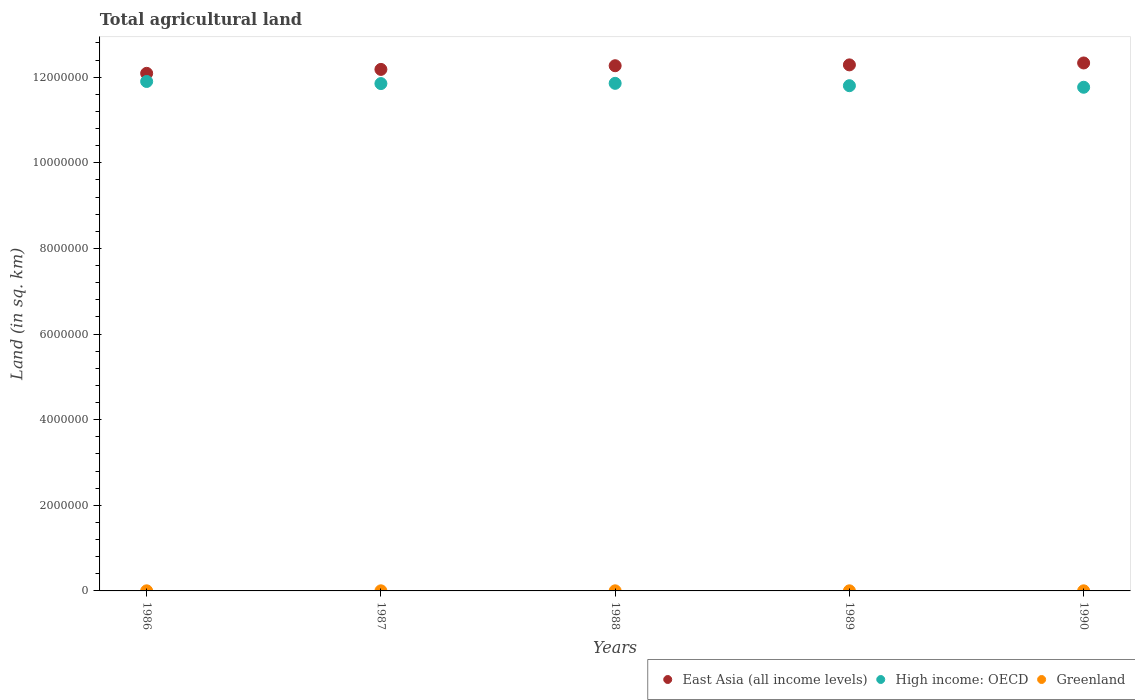How many different coloured dotlines are there?
Make the answer very short. 3. Is the number of dotlines equal to the number of legend labels?
Ensure brevity in your answer.  Yes. What is the total agricultural land in Greenland in 1988?
Your response must be concise. 2354. Across all years, what is the maximum total agricultural land in High income: OECD?
Ensure brevity in your answer.  1.19e+07. Across all years, what is the minimum total agricultural land in High income: OECD?
Give a very brief answer. 1.18e+07. In which year was the total agricultural land in East Asia (all income levels) minimum?
Provide a succinct answer. 1986. What is the total total agricultural land in High income: OECD in the graph?
Provide a short and direct response. 5.92e+07. What is the difference between the total agricultural land in East Asia (all income levels) in 1986 and that in 1987?
Offer a very short reply. -9.19e+04. What is the difference between the total agricultural land in Greenland in 1986 and the total agricultural land in High income: OECD in 1987?
Your response must be concise. -1.18e+07. What is the average total agricultural land in Greenland per year?
Provide a short and direct response. 2354.2. In the year 1986, what is the difference between the total agricultural land in East Asia (all income levels) and total agricultural land in High income: OECD?
Make the answer very short. 1.90e+05. What is the ratio of the total agricultural land in Greenland in 1988 to that in 1990?
Make the answer very short. 1. Is the total agricultural land in East Asia (all income levels) in 1988 less than that in 1989?
Your answer should be compact. Yes. What is the difference between the highest and the lowest total agricultural land in High income: OECD?
Give a very brief answer. 1.35e+05. Does the total agricultural land in High income: OECD monotonically increase over the years?
Give a very brief answer. No. Is the total agricultural land in High income: OECD strictly greater than the total agricultural land in East Asia (all income levels) over the years?
Your answer should be compact. No. How many dotlines are there?
Offer a terse response. 3. How many years are there in the graph?
Provide a succinct answer. 5. What is the difference between two consecutive major ticks on the Y-axis?
Provide a succinct answer. 2.00e+06. Are the values on the major ticks of Y-axis written in scientific E-notation?
Give a very brief answer. No. Does the graph contain any zero values?
Your answer should be compact. No. Where does the legend appear in the graph?
Offer a terse response. Bottom right. How many legend labels are there?
Offer a very short reply. 3. How are the legend labels stacked?
Offer a very short reply. Horizontal. What is the title of the graph?
Give a very brief answer. Total agricultural land. What is the label or title of the X-axis?
Keep it short and to the point. Years. What is the label or title of the Y-axis?
Keep it short and to the point. Land (in sq. km). What is the Land (in sq. km) of East Asia (all income levels) in 1986?
Your answer should be compact. 1.21e+07. What is the Land (in sq. km) of High income: OECD in 1986?
Make the answer very short. 1.19e+07. What is the Land (in sq. km) of Greenland in 1986?
Your answer should be very brief. 2354. What is the Land (in sq. km) in East Asia (all income levels) in 1987?
Offer a terse response. 1.22e+07. What is the Land (in sq. km) in High income: OECD in 1987?
Your answer should be compact. 1.19e+07. What is the Land (in sq. km) of Greenland in 1987?
Provide a succinct answer. 2354. What is the Land (in sq. km) of East Asia (all income levels) in 1988?
Offer a terse response. 1.23e+07. What is the Land (in sq. km) in High income: OECD in 1988?
Give a very brief answer. 1.19e+07. What is the Land (in sq. km) in Greenland in 1988?
Offer a terse response. 2354. What is the Land (in sq. km) of East Asia (all income levels) in 1989?
Offer a very short reply. 1.23e+07. What is the Land (in sq. km) of High income: OECD in 1989?
Make the answer very short. 1.18e+07. What is the Land (in sq. km) of Greenland in 1989?
Provide a succinct answer. 2354. What is the Land (in sq. km) of East Asia (all income levels) in 1990?
Provide a succinct answer. 1.23e+07. What is the Land (in sq. km) of High income: OECD in 1990?
Ensure brevity in your answer.  1.18e+07. What is the Land (in sq. km) in Greenland in 1990?
Your response must be concise. 2355. Across all years, what is the maximum Land (in sq. km) of East Asia (all income levels)?
Your answer should be very brief. 1.23e+07. Across all years, what is the maximum Land (in sq. km) of High income: OECD?
Your response must be concise. 1.19e+07. Across all years, what is the maximum Land (in sq. km) of Greenland?
Offer a terse response. 2355. Across all years, what is the minimum Land (in sq. km) of East Asia (all income levels)?
Make the answer very short. 1.21e+07. Across all years, what is the minimum Land (in sq. km) of High income: OECD?
Offer a terse response. 1.18e+07. Across all years, what is the minimum Land (in sq. km) in Greenland?
Give a very brief answer. 2354. What is the total Land (in sq. km) in East Asia (all income levels) in the graph?
Your answer should be very brief. 6.12e+07. What is the total Land (in sq. km) in High income: OECD in the graph?
Ensure brevity in your answer.  5.92e+07. What is the total Land (in sq. km) in Greenland in the graph?
Provide a succinct answer. 1.18e+04. What is the difference between the Land (in sq. km) of East Asia (all income levels) in 1986 and that in 1987?
Make the answer very short. -9.19e+04. What is the difference between the Land (in sq. km) of High income: OECD in 1986 and that in 1987?
Offer a very short reply. 4.92e+04. What is the difference between the Land (in sq. km) of East Asia (all income levels) in 1986 and that in 1988?
Provide a short and direct response. -1.78e+05. What is the difference between the Land (in sq. km) in High income: OECD in 1986 and that in 1988?
Provide a short and direct response. 4.37e+04. What is the difference between the Land (in sq. km) in Greenland in 1986 and that in 1988?
Make the answer very short. 0. What is the difference between the Land (in sq. km) in East Asia (all income levels) in 1986 and that in 1989?
Give a very brief answer. -1.98e+05. What is the difference between the Land (in sq. km) of High income: OECD in 1986 and that in 1989?
Offer a terse response. 9.88e+04. What is the difference between the Land (in sq. km) in East Asia (all income levels) in 1986 and that in 1990?
Provide a succinct answer. -2.42e+05. What is the difference between the Land (in sq. km) in High income: OECD in 1986 and that in 1990?
Give a very brief answer. 1.35e+05. What is the difference between the Land (in sq. km) of Greenland in 1986 and that in 1990?
Provide a short and direct response. -1. What is the difference between the Land (in sq. km) of East Asia (all income levels) in 1987 and that in 1988?
Make the answer very short. -8.59e+04. What is the difference between the Land (in sq. km) in High income: OECD in 1987 and that in 1988?
Give a very brief answer. -5413. What is the difference between the Land (in sq. km) in Greenland in 1987 and that in 1988?
Provide a short and direct response. 0. What is the difference between the Land (in sq. km) of East Asia (all income levels) in 1987 and that in 1989?
Your answer should be very brief. -1.06e+05. What is the difference between the Land (in sq. km) of High income: OECD in 1987 and that in 1989?
Your response must be concise. 4.96e+04. What is the difference between the Land (in sq. km) of Greenland in 1987 and that in 1989?
Ensure brevity in your answer.  0. What is the difference between the Land (in sq. km) of East Asia (all income levels) in 1987 and that in 1990?
Ensure brevity in your answer.  -1.50e+05. What is the difference between the Land (in sq. km) of High income: OECD in 1987 and that in 1990?
Your answer should be compact. 8.59e+04. What is the difference between the Land (in sq. km) of East Asia (all income levels) in 1988 and that in 1989?
Provide a short and direct response. -1.99e+04. What is the difference between the Land (in sq. km) of High income: OECD in 1988 and that in 1989?
Your answer should be very brief. 5.50e+04. What is the difference between the Land (in sq. km) of Greenland in 1988 and that in 1989?
Your answer should be very brief. 0. What is the difference between the Land (in sq. km) in East Asia (all income levels) in 1988 and that in 1990?
Offer a terse response. -6.46e+04. What is the difference between the Land (in sq. km) of High income: OECD in 1988 and that in 1990?
Ensure brevity in your answer.  9.14e+04. What is the difference between the Land (in sq. km) in Greenland in 1988 and that in 1990?
Give a very brief answer. -1. What is the difference between the Land (in sq. km) in East Asia (all income levels) in 1989 and that in 1990?
Offer a very short reply. -4.46e+04. What is the difference between the Land (in sq. km) in High income: OECD in 1989 and that in 1990?
Make the answer very short. 3.63e+04. What is the difference between the Land (in sq. km) in East Asia (all income levels) in 1986 and the Land (in sq. km) in High income: OECD in 1987?
Ensure brevity in your answer.  2.39e+05. What is the difference between the Land (in sq. km) of East Asia (all income levels) in 1986 and the Land (in sq. km) of Greenland in 1987?
Provide a short and direct response. 1.21e+07. What is the difference between the Land (in sq. km) of High income: OECD in 1986 and the Land (in sq. km) of Greenland in 1987?
Make the answer very short. 1.19e+07. What is the difference between the Land (in sq. km) of East Asia (all income levels) in 1986 and the Land (in sq. km) of High income: OECD in 1988?
Make the answer very short. 2.34e+05. What is the difference between the Land (in sq. km) in East Asia (all income levels) in 1986 and the Land (in sq. km) in Greenland in 1988?
Your answer should be compact. 1.21e+07. What is the difference between the Land (in sq. km) in High income: OECD in 1986 and the Land (in sq. km) in Greenland in 1988?
Offer a very short reply. 1.19e+07. What is the difference between the Land (in sq. km) of East Asia (all income levels) in 1986 and the Land (in sq. km) of High income: OECD in 1989?
Make the answer very short. 2.89e+05. What is the difference between the Land (in sq. km) of East Asia (all income levels) in 1986 and the Land (in sq. km) of Greenland in 1989?
Offer a very short reply. 1.21e+07. What is the difference between the Land (in sq. km) of High income: OECD in 1986 and the Land (in sq. km) of Greenland in 1989?
Your answer should be compact. 1.19e+07. What is the difference between the Land (in sq. km) in East Asia (all income levels) in 1986 and the Land (in sq. km) in High income: OECD in 1990?
Offer a terse response. 3.25e+05. What is the difference between the Land (in sq. km) in East Asia (all income levels) in 1986 and the Land (in sq. km) in Greenland in 1990?
Your answer should be very brief. 1.21e+07. What is the difference between the Land (in sq. km) of High income: OECD in 1986 and the Land (in sq. km) of Greenland in 1990?
Offer a very short reply. 1.19e+07. What is the difference between the Land (in sq. km) of East Asia (all income levels) in 1987 and the Land (in sq. km) of High income: OECD in 1988?
Provide a short and direct response. 3.26e+05. What is the difference between the Land (in sq. km) of East Asia (all income levels) in 1987 and the Land (in sq. km) of Greenland in 1988?
Offer a terse response. 1.22e+07. What is the difference between the Land (in sq. km) of High income: OECD in 1987 and the Land (in sq. km) of Greenland in 1988?
Offer a very short reply. 1.18e+07. What is the difference between the Land (in sq. km) in East Asia (all income levels) in 1987 and the Land (in sq. km) in High income: OECD in 1989?
Offer a very short reply. 3.81e+05. What is the difference between the Land (in sq. km) of East Asia (all income levels) in 1987 and the Land (in sq. km) of Greenland in 1989?
Offer a very short reply. 1.22e+07. What is the difference between the Land (in sq. km) in High income: OECD in 1987 and the Land (in sq. km) in Greenland in 1989?
Provide a succinct answer. 1.18e+07. What is the difference between the Land (in sq. km) in East Asia (all income levels) in 1987 and the Land (in sq. km) in High income: OECD in 1990?
Your answer should be very brief. 4.17e+05. What is the difference between the Land (in sq. km) in East Asia (all income levels) in 1987 and the Land (in sq. km) in Greenland in 1990?
Your answer should be very brief. 1.22e+07. What is the difference between the Land (in sq. km) of High income: OECD in 1987 and the Land (in sq. km) of Greenland in 1990?
Keep it short and to the point. 1.18e+07. What is the difference between the Land (in sq. km) of East Asia (all income levels) in 1988 and the Land (in sq. km) of High income: OECD in 1989?
Your answer should be compact. 4.66e+05. What is the difference between the Land (in sq. km) of East Asia (all income levels) in 1988 and the Land (in sq. km) of Greenland in 1989?
Offer a very short reply. 1.23e+07. What is the difference between the Land (in sq. km) in High income: OECD in 1988 and the Land (in sq. km) in Greenland in 1989?
Your answer should be very brief. 1.19e+07. What is the difference between the Land (in sq. km) in East Asia (all income levels) in 1988 and the Land (in sq. km) in High income: OECD in 1990?
Provide a short and direct response. 5.03e+05. What is the difference between the Land (in sq. km) in East Asia (all income levels) in 1988 and the Land (in sq. km) in Greenland in 1990?
Your answer should be compact. 1.23e+07. What is the difference between the Land (in sq. km) of High income: OECD in 1988 and the Land (in sq. km) of Greenland in 1990?
Provide a short and direct response. 1.19e+07. What is the difference between the Land (in sq. km) of East Asia (all income levels) in 1989 and the Land (in sq. km) of High income: OECD in 1990?
Offer a terse response. 5.23e+05. What is the difference between the Land (in sq. km) of East Asia (all income levels) in 1989 and the Land (in sq. km) of Greenland in 1990?
Provide a succinct answer. 1.23e+07. What is the difference between the Land (in sq. km) of High income: OECD in 1989 and the Land (in sq. km) of Greenland in 1990?
Offer a very short reply. 1.18e+07. What is the average Land (in sq. km) in East Asia (all income levels) per year?
Offer a very short reply. 1.22e+07. What is the average Land (in sq. km) in High income: OECD per year?
Your answer should be compact. 1.18e+07. What is the average Land (in sq. km) of Greenland per year?
Keep it short and to the point. 2354.2. In the year 1986, what is the difference between the Land (in sq. km) in East Asia (all income levels) and Land (in sq. km) in High income: OECD?
Your response must be concise. 1.90e+05. In the year 1986, what is the difference between the Land (in sq. km) in East Asia (all income levels) and Land (in sq. km) in Greenland?
Keep it short and to the point. 1.21e+07. In the year 1986, what is the difference between the Land (in sq. km) of High income: OECD and Land (in sq. km) of Greenland?
Provide a succinct answer. 1.19e+07. In the year 1987, what is the difference between the Land (in sq. km) in East Asia (all income levels) and Land (in sq. km) in High income: OECD?
Your response must be concise. 3.31e+05. In the year 1987, what is the difference between the Land (in sq. km) of East Asia (all income levels) and Land (in sq. km) of Greenland?
Make the answer very short. 1.22e+07. In the year 1987, what is the difference between the Land (in sq. km) of High income: OECD and Land (in sq. km) of Greenland?
Give a very brief answer. 1.18e+07. In the year 1988, what is the difference between the Land (in sq. km) of East Asia (all income levels) and Land (in sq. km) of High income: OECD?
Offer a very short reply. 4.11e+05. In the year 1988, what is the difference between the Land (in sq. km) in East Asia (all income levels) and Land (in sq. km) in Greenland?
Your response must be concise. 1.23e+07. In the year 1988, what is the difference between the Land (in sq. km) of High income: OECD and Land (in sq. km) of Greenland?
Offer a terse response. 1.19e+07. In the year 1989, what is the difference between the Land (in sq. km) of East Asia (all income levels) and Land (in sq. km) of High income: OECD?
Offer a terse response. 4.86e+05. In the year 1989, what is the difference between the Land (in sq. km) of East Asia (all income levels) and Land (in sq. km) of Greenland?
Your response must be concise. 1.23e+07. In the year 1989, what is the difference between the Land (in sq. km) of High income: OECD and Land (in sq. km) of Greenland?
Your answer should be very brief. 1.18e+07. In the year 1990, what is the difference between the Land (in sq. km) of East Asia (all income levels) and Land (in sq. km) of High income: OECD?
Your response must be concise. 5.67e+05. In the year 1990, what is the difference between the Land (in sq. km) of East Asia (all income levels) and Land (in sq. km) of Greenland?
Keep it short and to the point. 1.23e+07. In the year 1990, what is the difference between the Land (in sq. km) in High income: OECD and Land (in sq. km) in Greenland?
Give a very brief answer. 1.18e+07. What is the ratio of the Land (in sq. km) in East Asia (all income levels) in 1986 to that in 1987?
Your answer should be compact. 0.99. What is the ratio of the Land (in sq. km) of High income: OECD in 1986 to that in 1987?
Give a very brief answer. 1. What is the ratio of the Land (in sq. km) in Greenland in 1986 to that in 1987?
Your response must be concise. 1. What is the ratio of the Land (in sq. km) in East Asia (all income levels) in 1986 to that in 1988?
Ensure brevity in your answer.  0.99. What is the ratio of the Land (in sq. km) in High income: OECD in 1986 to that in 1988?
Make the answer very short. 1. What is the ratio of the Land (in sq. km) in East Asia (all income levels) in 1986 to that in 1989?
Keep it short and to the point. 0.98. What is the ratio of the Land (in sq. km) in High income: OECD in 1986 to that in 1989?
Your answer should be very brief. 1.01. What is the ratio of the Land (in sq. km) of Greenland in 1986 to that in 1989?
Offer a terse response. 1. What is the ratio of the Land (in sq. km) in East Asia (all income levels) in 1986 to that in 1990?
Give a very brief answer. 0.98. What is the ratio of the Land (in sq. km) in High income: OECD in 1986 to that in 1990?
Make the answer very short. 1.01. What is the ratio of the Land (in sq. km) of High income: OECD in 1987 to that in 1988?
Your answer should be compact. 1. What is the ratio of the Land (in sq. km) in Greenland in 1987 to that in 1988?
Give a very brief answer. 1. What is the ratio of the Land (in sq. km) of Greenland in 1987 to that in 1989?
Provide a succinct answer. 1. What is the ratio of the Land (in sq. km) in East Asia (all income levels) in 1987 to that in 1990?
Ensure brevity in your answer.  0.99. What is the ratio of the Land (in sq. km) of High income: OECD in 1987 to that in 1990?
Provide a short and direct response. 1.01. What is the ratio of the Land (in sq. km) of Greenland in 1988 to that in 1989?
Give a very brief answer. 1. What is the ratio of the Land (in sq. km) of East Asia (all income levels) in 1989 to that in 1990?
Provide a short and direct response. 1. What is the ratio of the Land (in sq. km) in High income: OECD in 1989 to that in 1990?
Make the answer very short. 1. What is the difference between the highest and the second highest Land (in sq. km) of East Asia (all income levels)?
Ensure brevity in your answer.  4.46e+04. What is the difference between the highest and the second highest Land (in sq. km) of High income: OECD?
Provide a succinct answer. 4.37e+04. What is the difference between the highest and the second highest Land (in sq. km) in Greenland?
Keep it short and to the point. 1. What is the difference between the highest and the lowest Land (in sq. km) in East Asia (all income levels)?
Offer a very short reply. 2.42e+05. What is the difference between the highest and the lowest Land (in sq. km) in High income: OECD?
Make the answer very short. 1.35e+05. What is the difference between the highest and the lowest Land (in sq. km) of Greenland?
Offer a terse response. 1. 